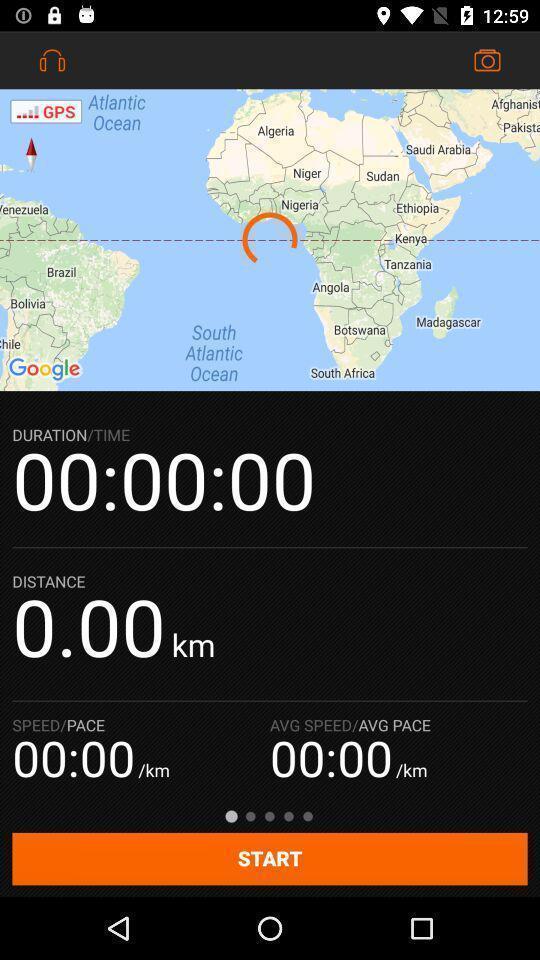Please provide a description for this image. Page showing interface for a sports tracker app. 